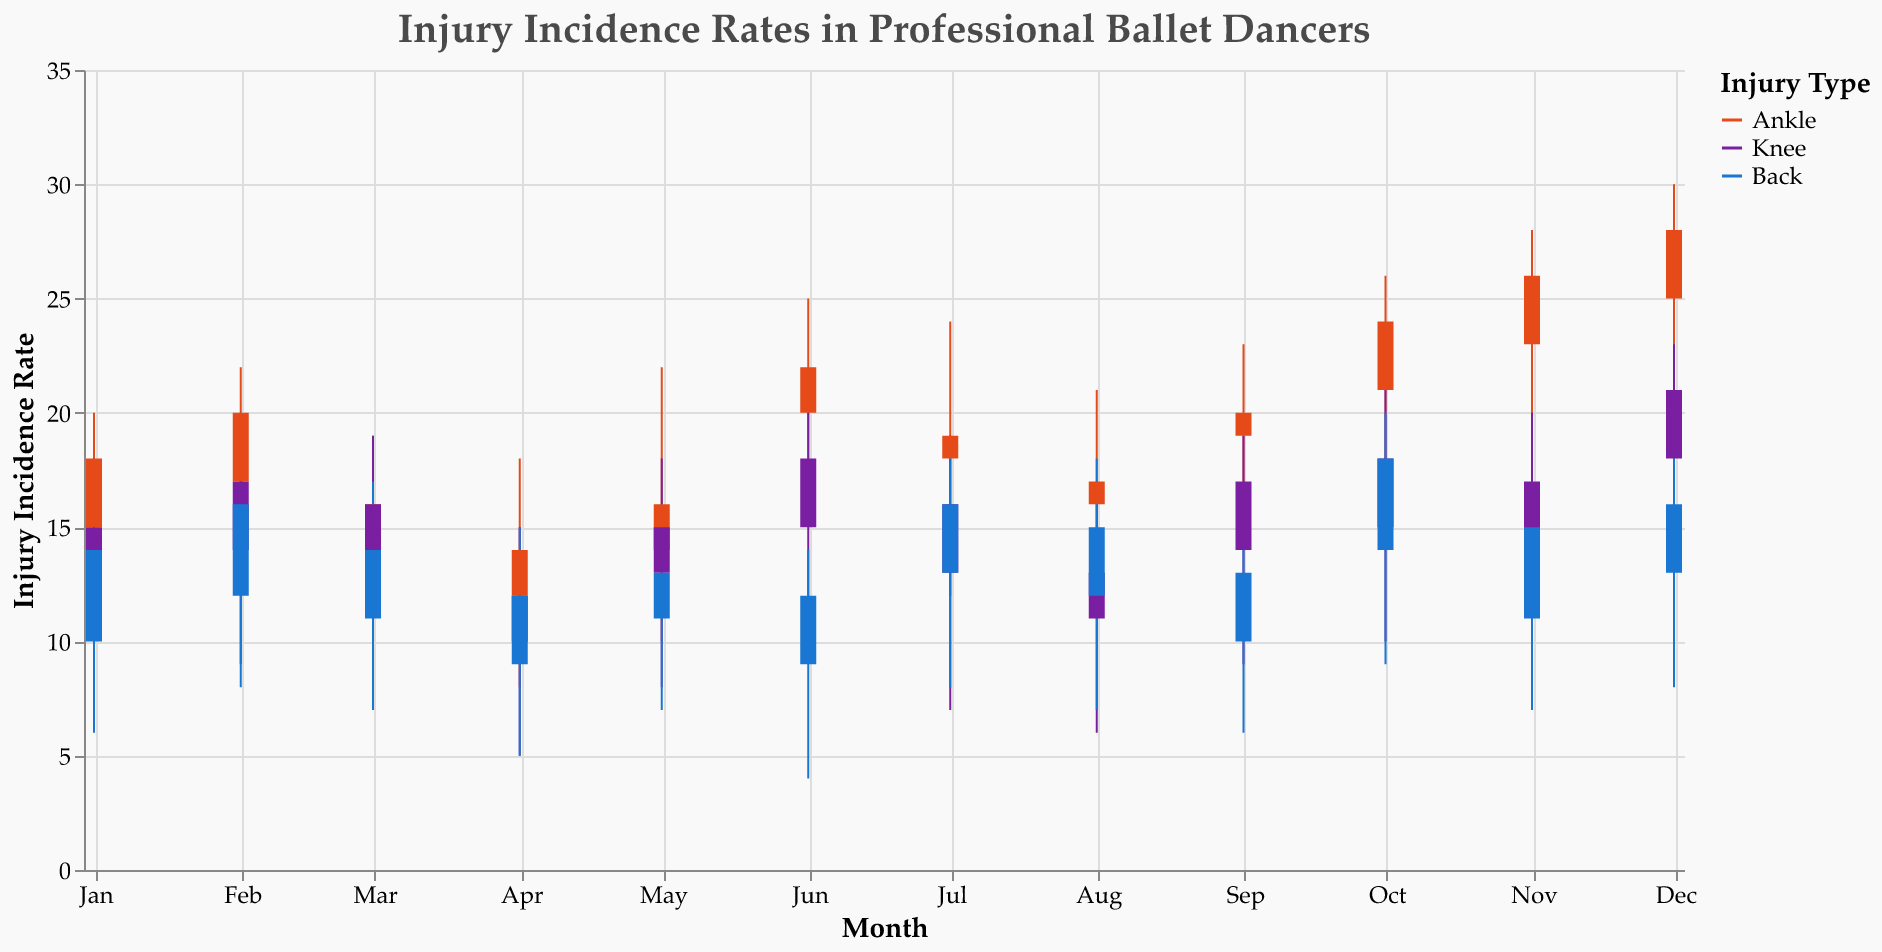What's the title of the figure? The title is usually displayed at the top of the figure and is a descriptive text that summarizes the content of the figure. The title of the candlestick plot is "Injury Incidence Rates in Professional Ballet Dancers."
Answer: Injury Incidence Rates in Professional Ballet Dancers What is the y-axis title? The y-axis title is the label that indicates what the values on the y-axis represent. According to the provided code, the title of the y-axis is "Injury Incidence Rate."
Answer: Injury Incidence Rate In which month did ankle injuries close at 28? To find this information, look at the candlestick bars corresponding to ankle injuries and check the 'Close' value of the plot for different months. December has this value.
Answer: December Which injury type had its highest incidence in October? Look for the highest value on the y-axis in the month of October for each injury type. According to the data, back injuries had the highest value at 20.
Answer: Back Compare the opening values of knee injuries between January and December. Which month had a higher opening value? Check the 'Open' values for knee injuries in January and December. January's opening value is 12, while December's is 18, making December higher.
Answer: December What was the lowest incidence rate for back injuries in June? Identify the 'Low' value for back injuries in June. According to the data, the lowest incidence rate is 4.
Answer: 4 What is the difference between the highest and lowest incidence rates for ankle injuries in March? Subtract the 'Low' value from the 'High' value for ankle injuries in March. The high is 19 and the low is 9, so the difference is 19 - 9 = 10.
Answer: 10 Which injury type showed a decreasing trend in its closing values from January to April? To identify a decreasing trend, compare the 'Close' values from January to April for each injury type. The 'Close' values for ankle injuries go from 18 to 14, which shows a decreasing trend.
Answer: Ankle Which month had the highest incidence rate for knee injuries? Look at the 'High' values for each month for knee injuries. December has the highest value, which is 23.
Answer: December 